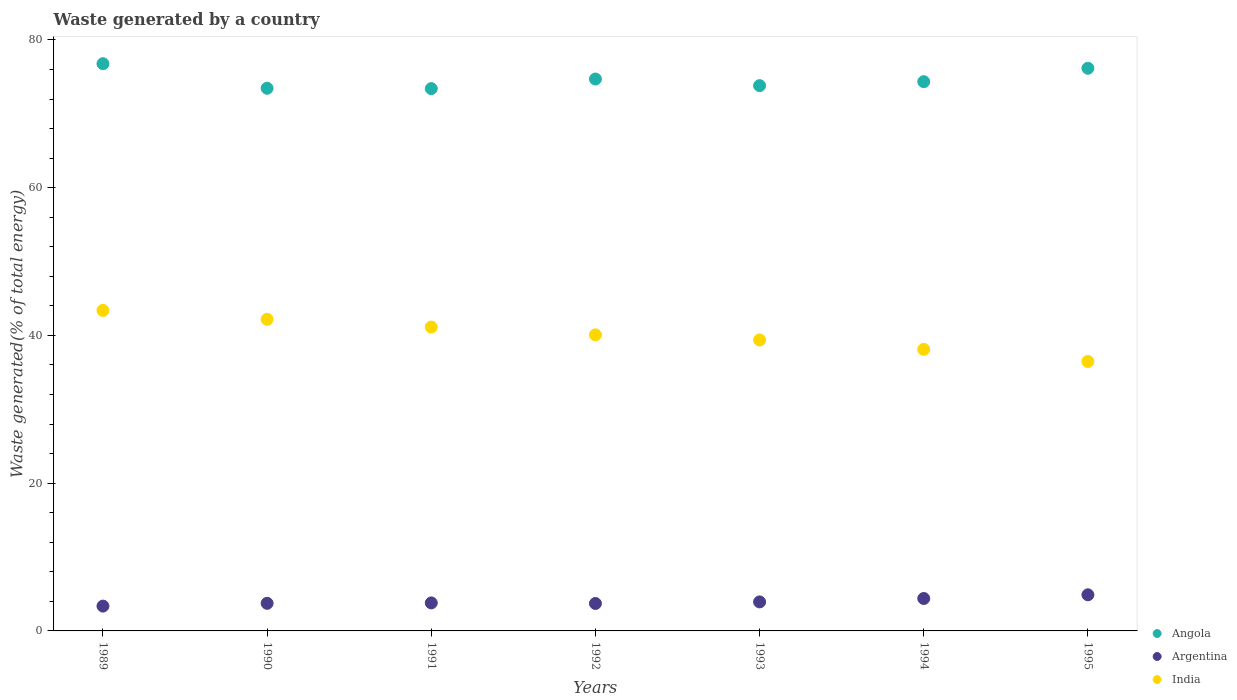Is the number of dotlines equal to the number of legend labels?
Your answer should be compact. Yes. What is the total waste generated in India in 1992?
Your answer should be compact. 40.08. Across all years, what is the maximum total waste generated in Argentina?
Offer a very short reply. 4.89. Across all years, what is the minimum total waste generated in Argentina?
Your answer should be very brief. 3.36. In which year was the total waste generated in India maximum?
Provide a short and direct response. 1989. In which year was the total waste generated in Argentina minimum?
Make the answer very short. 1989. What is the total total waste generated in Angola in the graph?
Your answer should be very brief. 522.7. What is the difference between the total waste generated in Argentina in 1992 and that in 1994?
Offer a very short reply. -0.67. What is the difference between the total waste generated in Angola in 1994 and the total waste generated in Argentina in 1992?
Offer a terse response. 70.64. What is the average total waste generated in Argentina per year?
Ensure brevity in your answer.  3.97. In the year 1990, what is the difference between the total waste generated in Angola and total waste generated in Argentina?
Make the answer very short. 69.72. In how many years, is the total waste generated in Argentina greater than 48 %?
Provide a succinct answer. 0. What is the ratio of the total waste generated in Argentina in 1990 to that in 1995?
Offer a very short reply. 0.76. Is the total waste generated in Argentina in 1991 less than that in 1992?
Provide a succinct answer. No. What is the difference between the highest and the second highest total waste generated in Angola?
Ensure brevity in your answer.  0.62. What is the difference between the highest and the lowest total waste generated in Angola?
Offer a very short reply. 3.37. Is the sum of the total waste generated in India in 1989 and 1995 greater than the maximum total waste generated in Angola across all years?
Provide a succinct answer. Yes. Is it the case that in every year, the sum of the total waste generated in India and total waste generated in Argentina  is greater than the total waste generated in Angola?
Your answer should be very brief. No. Is the total waste generated in Angola strictly greater than the total waste generated in Argentina over the years?
Ensure brevity in your answer.  Yes. How many years are there in the graph?
Keep it short and to the point. 7. Are the values on the major ticks of Y-axis written in scientific E-notation?
Your response must be concise. No. Does the graph contain any zero values?
Provide a short and direct response. No. Does the graph contain grids?
Make the answer very short. No. How many legend labels are there?
Provide a succinct answer. 3. How are the legend labels stacked?
Offer a very short reply. Vertical. What is the title of the graph?
Your answer should be compact. Waste generated by a country. Does "Senegal" appear as one of the legend labels in the graph?
Offer a very short reply. No. What is the label or title of the Y-axis?
Ensure brevity in your answer.  Waste generated(% of total energy). What is the Waste generated(% of total energy) in Angola in 1989?
Provide a succinct answer. 76.79. What is the Waste generated(% of total energy) of Argentina in 1989?
Give a very brief answer. 3.36. What is the Waste generated(% of total energy) in India in 1989?
Your answer should be compact. 43.39. What is the Waste generated(% of total energy) of Angola in 1990?
Give a very brief answer. 73.46. What is the Waste generated(% of total energy) of Argentina in 1990?
Make the answer very short. 3.74. What is the Waste generated(% of total energy) in India in 1990?
Make the answer very short. 42.18. What is the Waste generated(% of total energy) in Angola in 1991?
Offer a terse response. 73.42. What is the Waste generated(% of total energy) of Argentina in 1991?
Provide a succinct answer. 3.79. What is the Waste generated(% of total energy) of India in 1991?
Offer a very short reply. 41.13. What is the Waste generated(% of total energy) in Angola in 1992?
Offer a very short reply. 74.71. What is the Waste generated(% of total energy) in Argentina in 1992?
Provide a short and direct response. 3.71. What is the Waste generated(% of total energy) of India in 1992?
Provide a succinct answer. 40.08. What is the Waste generated(% of total energy) in Angola in 1993?
Offer a very short reply. 73.82. What is the Waste generated(% of total energy) of Argentina in 1993?
Offer a very short reply. 3.93. What is the Waste generated(% of total energy) in India in 1993?
Offer a very short reply. 39.39. What is the Waste generated(% of total energy) of Angola in 1994?
Your answer should be compact. 74.35. What is the Waste generated(% of total energy) of Argentina in 1994?
Your answer should be compact. 4.39. What is the Waste generated(% of total energy) of India in 1994?
Ensure brevity in your answer.  38.12. What is the Waste generated(% of total energy) in Angola in 1995?
Make the answer very short. 76.17. What is the Waste generated(% of total energy) in Argentina in 1995?
Make the answer very short. 4.89. What is the Waste generated(% of total energy) of India in 1995?
Provide a succinct answer. 36.47. Across all years, what is the maximum Waste generated(% of total energy) in Angola?
Offer a very short reply. 76.79. Across all years, what is the maximum Waste generated(% of total energy) in Argentina?
Give a very brief answer. 4.89. Across all years, what is the maximum Waste generated(% of total energy) in India?
Provide a succinct answer. 43.39. Across all years, what is the minimum Waste generated(% of total energy) of Angola?
Provide a short and direct response. 73.42. Across all years, what is the minimum Waste generated(% of total energy) of Argentina?
Your response must be concise. 3.36. Across all years, what is the minimum Waste generated(% of total energy) of India?
Your answer should be compact. 36.47. What is the total Waste generated(% of total energy) in Angola in the graph?
Ensure brevity in your answer.  522.7. What is the total Waste generated(% of total energy) of Argentina in the graph?
Offer a terse response. 27.81. What is the total Waste generated(% of total energy) in India in the graph?
Offer a very short reply. 280.75. What is the difference between the Waste generated(% of total energy) of Angola in 1989 and that in 1990?
Keep it short and to the point. 3.33. What is the difference between the Waste generated(% of total energy) of Argentina in 1989 and that in 1990?
Your response must be concise. -0.38. What is the difference between the Waste generated(% of total energy) of India in 1989 and that in 1990?
Offer a terse response. 1.2. What is the difference between the Waste generated(% of total energy) of Angola in 1989 and that in 1991?
Ensure brevity in your answer.  3.37. What is the difference between the Waste generated(% of total energy) in Argentina in 1989 and that in 1991?
Offer a terse response. -0.43. What is the difference between the Waste generated(% of total energy) of India in 1989 and that in 1991?
Make the answer very short. 2.25. What is the difference between the Waste generated(% of total energy) in Angola in 1989 and that in 1992?
Make the answer very short. 2.08. What is the difference between the Waste generated(% of total energy) in Argentina in 1989 and that in 1992?
Provide a succinct answer. -0.35. What is the difference between the Waste generated(% of total energy) of India in 1989 and that in 1992?
Your response must be concise. 3.31. What is the difference between the Waste generated(% of total energy) of Angola in 1989 and that in 1993?
Ensure brevity in your answer.  2.97. What is the difference between the Waste generated(% of total energy) in Argentina in 1989 and that in 1993?
Your answer should be compact. -0.57. What is the difference between the Waste generated(% of total energy) of India in 1989 and that in 1993?
Provide a short and direct response. 4. What is the difference between the Waste generated(% of total energy) in Angola in 1989 and that in 1994?
Your answer should be compact. 2.44. What is the difference between the Waste generated(% of total energy) of Argentina in 1989 and that in 1994?
Offer a terse response. -1.03. What is the difference between the Waste generated(% of total energy) in India in 1989 and that in 1994?
Your answer should be very brief. 5.27. What is the difference between the Waste generated(% of total energy) in Angola in 1989 and that in 1995?
Your answer should be very brief. 0.62. What is the difference between the Waste generated(% of total energy) of Argentina in 1989 and that in 1995?
Offer a terse response. -1.53. What is the difference between the Waste generated(% of total energy) in India in 1989 and that in 1995?
Your response must be concise. 6.91. What is the difference between the Waste generated(% of total energy) of Angola in 1990 and that in 1991?
Ensure brevity in your answer.  0.04. What is the difference between the Waste generated(% of total energy) of Argentina in 1990 and that in 1991?
Provide a short and direct response. -0.06. What is the difference between the Waste generated(% of total energy) in India in 1990 and that in 1991?
Make the answer very short. 1.05. What is the difference between the Waste generated(% of total energy) of Angola in 1990 and that in 1992?
Make the answer very short. -1.25. What is the difference between the Waste generated(% of total energy) of Argentina in 1990 and that in 1992?
Make the answer very short. 0.02. What is the difference between the Waste generated(% of total energy) of India in 1990 and that in 1992?
Your answer should be compact. 2.1. What is the difference between the Waste generated(% of total energy) of Angola in 1990 and that in 1993?
Keep it short and to the point. -0.36. What is the difference between the Waste generated(% of total energy) in Argentina in 1990 and that in 1993?
Provide a succinct answer. -0.19. What is the difference between the Waste generated(% of total energy) in India in 1990 and that in 1993?
Ensure brevity in your answer.  2.8. What is the difference between the Waste generated(% of total energy) of Angola in 1990 and that in 1994?
Offer a terse response. -0.89. What is the difference between the Waste generated(% of total energy) of Argentina in 1990 and that in 1994?
Give a very brief answer. -0.65. What is the difference between the Waste generated(% of total energy) of India in 1990 and that in 1994?
Provide a succinct answer. 4.06. What is the difference between the Waste generated(% of total energy) of Angola in 1990 and that in 1995?
Offer a terse response. -2.71. What is the difference between the Waste generated(% of total energy) in Argentina in 1990 and that in 1995?
Offer a very short reply. -1.15. What is the difference between the Waste generated(% of total energy) in India in 1990 and that in 1995?
Keep it short and to the point. 5.71. What is the difference between the Waste generated(% of total energy) of Angola in 1991 and that in 1992?
Your answer should be compact. -1.29. What is the difference between the Waste generated(% of total energy) in Argentina in 1991 and that in 1992?
Your response must be concise. 0.08. What is the difference between the Waste generated(% of total energy) of India in 1991 and that in 1992?
Make the answer very short. 1.06. What is the difference between the Waste generated(% of total energy) of Angola in 1991 and that in 1993?
Your answer should be compact. -0.4. What is the difference between the Waste generated(% of total energy) of Argentina in 1991 and that in 1993?
Give a very brief answer. -0.14. What is the difference between the Waste generated(% of total energy) in India in 1991 and that in 1993?
Your response must be concise. 1.75. What is the difference between the Waste generated(% of total energy) of Angola in 1991 and that in 1994?
Offer a very short reply. -0.94. What is the difference between the Waste generated(% of total energy) of Argentina in 1991 and that in 1994?
Make the answer very short. -0.6. What is the difference between the Waste generated(% of total energy) of India in 1991 and that in 1994?
Your answer should be very brief. 3.02. What is the difference between the Waste generated(% of total energy) of Angola in 1991 and that in 1995?
Your answer should be very brief. -2.75. What is the difference between the Waste generated(% of total energy) of Argentina in 1991 and that in 1995?
Your response must be concise. -1.1. What is the difference between the Waste generated(% of total energy) in India in 1991 and that in 1995?
Provide a short and direct response. 4.66. What is the difference between the Waste generated(% of total energy) of Angola in 1992 and that in 1993?
Offer a terse response. 0.89. What is the difference between the Waste generated(% of total energy) of Argentina in 1992 and that in 1993?
Give a very brief answer. -0.21. What is the difference between the Waste generated(% of total energy) in India in 1992 and that in 1993?
Give a very brief answer. 0.69. What is the difference between the Waste generated(% of total energy) of Angola in 1992 and that in 1994?
Your answer should be very brief. 0.36. What is the difference between the Waste generated(% of total energy) of Argentina in 1992 and that in 1994?
Your response must be concise. -0.67. What is the difference between the Waste generated(% of total energy) in India in 1992 and that in 1994?
Make the answer very short. 1.96. What is the difference between the Waste generated(% of total energy) of Angola in 1992 and that in 1995?
Ensure brevity in your answer.  -1.46. What is the difference between the Waste generated(% of total energy) in Argentina in 1992 and that in 1995?
Your response must be concise. -1.17. What is the difference between the Waste generated(% of total energy) of India in 1992 and that in 1995?
Your answer should be compact. 3.6. What is the difference between the Waste generated(% of total energy) in Angola in 1993 and that in 1994?
Offer a terse response. -0.53. What is the difference between the Waste generated(% of total energy) of Argentina in 1993 and that in 1994?
Offer a very short reply. -0.46. What is the difference between the Waste generated(% of total energy) of India in 1993 and that in 1994?
Give a very brief answer. 1.27. What is the difference between the Waste generated(% of total energy) in Angola in 1993 and that in 1995?
Your answer should be very brief. -2.35. What is the difference between the Waste generated(% of total energy) in Argentina in 1993 and that in 1995?
Offer a very short reply. -0.96. What is the difference between the Waste generated(% of total energy) in India in 1993 and that in 1995?
Make the answer very short. 2.91. What is the difference between the Waste generated(% of total energy) in Angola in 1994 and that in 1995?
Your answer should be compact. -1.82. What is the difference between the Waste generated(% of total energy) of Argentina in 1994 and that in 1995?
Your answer should be compact. -0.5. What is the difference between the Waste generated(% of total energy) of India in 1994 and that in 1995?
Keep it short and to the point. 1.65. What is the difference between the Waste generated(% of total energy) in Angola in 1989 and the Waste generated(% of total energy) in Argentina in 1990?
Keep it short and to the point. 73.05. What is the difference between the Waste generated(% of total energy) in Angola in 1989 and the Waste generated(% of total energy) in India in 1990?
Offer a very short reply. 34.61. What is the difference between the Waste generated(% of total energy) in Argentina in 1989 and the Waste generated(% of total energy) in India in 1990?
Your answer should be compact. -38.82. What is the difference between the Waste generated(% of total energy) of Angola in 1989 and the Waste generated(% of total energy) of Argentina in 1991?
Ensure brevity in your answer.  72.99. What is the difference between the Waste generated(% of total energy) in Angola in 1989 and the Waste generated(% of total energy) in India in 1991?
Ensure brevity in your answer.  35.65. What is the difference between the Waste generated(% of total energy) in Argentina in 1989 and the Waste generated(% of total energy) in India in 1991?
Ensure brevity in your answer.  -37.77. What is the difference between the Waste generated(% of total energy) in Angola in 1989 and the Waste generated(% of total energy) in Argentina in 1992?
Ensure brevity in your answer.  73.07. What is the difference between the Waste generated(% of total energy) in Angola in 1989 and the Waste generated(% of total energy) in India in 1992?
Provide a short and direct response. 36.71. What is the difference between the Waste generated(% of total energy) in Argentina in 1989 and the Waste generated(% of total energy) in India in 1992?
Your answer should be very brief. -36.72. What is the difference between the Waste generated(% of total energy) of Angola in 1989 and the Waste generated(% of total energy) of Argentina in 1993?
Your answer should be very brief. 72.86. What is the difference between the Waste generated(% of total energy) of Angola in 1989 and the Waste generated(% of total energy) of India in 1993?
Offer a very short reply. 37.4. What is the difference between the Waste generated(% of total energy) in Argentina in 1989 and the Waste generated(% of total energy) in India in 1993?
Provide a short and direct response. -36.02. What is the difference between the Waste generated(% of total energy) in Angola in 1989 and the Waste generated(% of total energy) in Argentina in 1994?
Ensure brevity in your answer.  72.4. What is the difference between the Waste generated(% of total energy) in Angola in 1989 and the Waste generated(% of total energy) in India in 1994?
Provide a succinct answer. 38.67. What is the difference between the Waste generated(% of total energy) in Argentina in 1989 and the Waste generated(% of total energy) in India in 1994?
Your response must be concise. -34.76. What is the difference between the Waste generated(% of total energy) in Angola in 1989 and the Waste generated(% of total energy) in Argentina in 1995?
Offer a very short reply. 71.9. What is the difference between the Waste generated(% of total energy) of Angola in 1989 and the Waste generated(% of total energy) of India in 1995?
Ensure brevity in your answer.  40.31. What is the difference between the Waste generated(% of total energy) of Argentina in 1989 and the Waste generated(% of total energy) of India in 1995?
Provide a short and direct response. -33.11. What is the difference between the Waste generated(% of total energy) of Angola in 1990 and the Waste generated(% of total energy) of Argentina in 1991?
Offer a terse response. 69.67. What is the difference between the Waste generated(% of total energy) in Angola in 1990 and the Waste generated(% of total energy) in India in 1991?
Keep it short and to the point. 32.33. What is the difference between the Waste generated(% of total energy) of Argentina in 1990 and the Waste generated(% of total energy) of India in 1991?
Provide a short and direct response. -37.4. What is the difference between the Waste generated(% of total energy) of Angola in 1990 and the Waste generated(% of total energy) of Argentina in 1992?
Your answer should be very brief. 69.75. What is the difference between the Waste generated(% of total energy) in Angola in 1990 and the Waste generated(% of total energy) in India in 1992?
Provide a succinct answer. 33.38. What is the difference between the Waste generated(% of total energy) in Argentina in 1990 and the Waste generated(% of total energy) in India in 1992?
Provide a succinct answer. -36.34. What is the difference between the Waste generated(% of total energy) of Angola in 1990 and the Waste generated(% of total energy) of Argentina in 1993?
Provide a succinct answer. 69.53. What is the difference between the Waste generated(% of total energy) in Angola in 1990 and the Waste generated(% of total energy) in India in 1993?
Offer a terse response. 34.07. What is the difference between the Waste generated(% of total energy) in Argentina in 1990 and the Waste generated(% of total energy) in India in 1993?
Offer a terse response. -35.65. What is the difference between the Waste generated(% of total energy) of Angola in 1990 and the Waste generated(% of total energy) of Argentina in 1994?
Offer a very short reply. 69.07. What is the difference between the Waste generated(% of total energy) of Angola in 1990 and the Waste generated(% of total energy) of India in 1994?
Offer a very short reply. 35.34. What is the difference between the Waste generated(% of total energy) in Argentina in 1990 and the Waste generated(% of total energy) in India in 1994?
Provide a succinct answer. -34.38. What is the difference between the Waste generated(% of total energy) of Angola in 1990 and the Waste generated(% of total energy) of Argentina in 1995?
Make the answer very short. 68.57. What is the difference between the Waste generated(% of total energy) in Angola in 1990 and the Waste generated(% of total energy) in India in 1995?
Offer a terse response. 36.99. What is the difference between the Waste generated(% of total energy) in Argentina in 1990 and the Waste generated(% of total energy) in India in 1995?
Offer a very short reply. -32.74. What is the difference between the Waste generated(% of total energy) of Angola in 1991 and the Waste generated(% of total energy) of Argentina in 1992?
Keep it short and to the point. 69.7. What is the difference between the Waste generated(% of total energy) of Angola in 1991 and the Waste generated(% of total energy) of India in 1992?
Provide a short and direct response. 33.34. What is the difference between the Waste generated(% of total energy) in Argentina in 1991 and the Waste generated(% of total energy) in India in 1992?
Your answer should be compact. -36.29. What is the difference between the Waste generated(% of total energy) in Angola in 1991 and the Waste generated(% of total energy) in Argentina in 1993?
Offer a very short reply. 69.49. What is the difference between the Waste generated(% of total energy) in Angola in 1991 and the Waste generated(% of total energy) in India in 1993?
Offer a very short reply. 34.03. What is the difference between the Waste generated(% of total energy) in Argentina in 1991 and the Waste generated(% of total energy) in India in 1993?
Provide a short and direct response. -35.59. What is the difference between the Waste generated(% of total energy) in Angola in 1991 and the Waste generated(% of total energy) in Argentina in 1994?
Offer a very short reply. 69.03. What is the difference between the Waste generated(% of total energy) in Angola in 1991 and the Waste generated(% of total energy) in India in 1994?
Provide a short and direct response. 35.3. What is the difference between the Waste generated(% of total energy) of Argentina in 1991 and the Waste generated(% of total energy) of India in 1994?
Provide a short and direct response. -34.33. What is the difference between the Waste generated(% of total energy) in Angola in 1991 and the Waste generated(% of total energy) in Argentina in 1995?
Your answer should be very brief. 68.53. What is the difference between the Waste generated(% of total energy) of Angola in 1991 and the Waste generated(% of total energy) of India in 1995?
Provide a succinct answer. 36.94. What is the difference between the Waste generated(% of total energy) in Argentina in 1991 and the Waste generated(% of total energy) in India in 1995?
Provide a short and direct response. -32.68. What is the difference between the Waste generated(% of total energy) in Angola in 1992 and the Waste generated(% of total energy) in Argentina in 1993?
Your answer should be very brief. 70.78. What is the difference between the Waste generated(% of total energy) in Angola in 1992 and the Waste generated(% of total energy) in India in 1993?
Your answer should be very brief. 35.32. What is the difference between the Waste generated(% of total energy) in Argentina in 1992 and the Waste generated(% of total energy) in India in 1993?
Your answer should be compact. -35.67. What is the difference between the Waste generated(% of total energy) of Angola in 1992 and the Waste generated(% of total energy) of Argentina in 1994?
Give a very brief answer. 70.32. What is the difference between the Waste generated(% of total energy) of Angola in 1992 and the Waste generated(% of total energy) of India in 1994?
Offer a terse response. 36.59. What is the difference between the Waste generated(% of total energy) of Argentina in 1992 and the Waste generated(% of total energy) of India in 1994?
Offer a terse response. -34.4. What is the difference between the Waste generated(% of total energy) in Angola in 1992 and the Waste generated(% of total energy) in Argentina in 1995?
Offer a very short reply. 69.82. What is the difference between the Waste generated(% of total energy) in Angola in 1992 and the Waste generated(% of total energy) in India in 1995?
Provide a short and direct response. 38.24. What is the difference between the Waste generated(% of total energy) in Argentina in 1992 and the Waste generated(% of total energy) in India in 1995?
Offer a very short reply. -32.76. What is the difference between the Waste generated(% of total energy) of Angola in 1993 and the Waste generated(% of total energy) of Argentina in 1994?
Make the answer very short. 69.43. What is the difference between the Waste generated(% of total energy) of Angola in 1993 and the Waste generated(% of total energy) of India in 1994?
Offer a terse response. 35.7. What is the difference between the Waste generated(% of total energy) in Argentina in 1993 and the Waste generated(% of total energy) in India in 1994?
Keep it short and to the point. -34.19. What is the difference between the Waste generated(% of total energy) of Angola in 1993 and the Waste generated(% of total energy) of Argentina in 1995?
Your answer should be very brief. 68.93. What is the difference between the Waste generated(% of total energy) in Angola in 1993 and the Waste generated(% of total energy) in India in 1995?
Your answer should be compact. 37.34. What is the difference between the Waste generated(% of total energy) in Argentina in 1993 and the Waste generated(% of total energy) in India in 1995?
Provide a succinct answer. -32.54. What is the difference between the Waste generated(% of total energy) in Angola in 1994 and the Waste generated(% of total energy) in Argentina in 1995?
Your response must be concise. 69.46. What is the difference between the Waste generated(% of total energy) of Angola in 1994 and the Waste generated(% of total energy) of India in 1995?
Offer a very short reply. 37.88. What is the difference between the Waste generated(% of total energy) of Argentina in 1994 and the Waste generated(% of total energy) of India in 1995?
Your answer should be very brief. -32.08. What is the average Waste generated(% of total energy) in Angola per year?
Provide a succinct answer. 74.67. What is the average Waste generated(% of total energy) in Argentina per year?
Make the answer very short. 3.97. What is the average Waste generated(% of total energy) of India per year?
Your answer should be compact. 40.11. In the year 1989, what is the difference between the Waste generated(% of total energy) in Angola and Waste generated(% of total energy) in Argentina?
Your answer should be compact. 73.43. In the year 1989, what is the difference between the Waste generated(% of total energy) in Angola and Waste generated(% of total energy) in India?
Provide a succinct answer. 33.4. In the year 1989, what is the difference between the Waste generated(% of total energy) in Argentina and Waste generated(% of total energy) in India?
Make the answer very short. -40.02. In the year 1990, what is the difference between the Waste generated(% of total energy) of Angola and Waste generated(% of total energy) of Argentina?
Your answer should be very brief. 69.72. In the year 1990, what is the difference between the Waste generated(% of total energy) of Angola and Waste generated(% of total energy) of India?
Your answer should be compact. 31.28. In the year 1990, what is the difference between the Waste generated(% of total energy) of Argentina and Waste generated(% of total energy) of India?
Your response must be concise. -38.44. In the year 1991, what is the difference between the Waste generated(% of total energy) of Angola and Waste generated(% of total energy) of Argentina?
Make the answer very short. 69.62. In the year 1991, what is the difference between the Waste generated(% of total energy) in Angola and Waste generated(% of total energy) in India?
Provide a short and direct response. 32.28. In the year 1991, what is the difference between the Waste generated(% of total energy) of Argentina and Waste generated(% of total energy) of India?
Provide a succinct answer. -37.34. In the year 1992, what is the difference between the Waste generated(% of total energy) in Angola and Waste generated(% of total energy) in Argentina?
Offer a terse response. 70.99. In the year 1992, what is the difference between the Waste generated(% of total energy) of Angola and Waste generated(% of total energy) of India?
Give a very brief answer. 34.63. In the year 1992, what is the difference between the Waste generated(% of total energy) in Argentina and Waste generated(% of total energy) in India?
Provide a short and direct response. -36.36. In the year 1993, what is the difference between the Waste generated(% of total energy) of Angola and Waste generated(% of total energy) of Argentina?
Make the answer very short. 69.89. In the year 1993, what is the difference between the Waste generated(% of total energy) in Angola and Waste generated(% of total energy) in India?
Provide a short and direct response. 34.43. In the year 1993, what is the difference between the Waste generated(% of total energy) of Argentina and Waste generated(% of total energy) of India?
Make the answer very short. -35.46. In the year 1994, what is the difference between the Waste generated(% of total energy) of Angola and Waste generated(% of total energy) of Argentina?
Provide a succinct answer. 69.96. In the year 1994, what is the difference between the Waste generated(% of total energy) of Angola and Waste generated(% of total energy) of India?
Ensure brevity in your answer.  36.23. In the year 1994, what is the difference between the Waste generated(% of total energy) in Argentina and Waste generated(% of total energy) in India?
Your response must be concise. -33.73. In the year 1995, what is the difference between the Waste generated(% of total energy) of Angola and Waste generated(% of total energy) of Argentina?
Provide a short and direct response. 71.28. In the year 1995, what is the difference between the Waste generated(% of total energy) in Angola and Waste generated(% of total energy) in India?
Provide a short and direct response. 39.7. In the year 1995, what is the difference between the Waste generated(% of total energy) of Argentina and Waste generated(% of total energy) of India?
Keep it short and to the point. -31.58. What is the ratio of the Waste generated(% of total energy) in Angola in 1989 to that in 1990?
Give a very brief answer. 1.05. What is the ratio of the Waste generated(% of total energy) of Argentina in 1989 to that in 1990?
Ensure brevity in your answer.  0.9. What is the ratio of the Waste generated(% of total energy) of India in 1989 to that in 1990?
Offer a very short reply. 1.03. What is the ratio of the Waste generated(% of total energy) in Angola in 1989 to that in 1991?
Ensure brevity in your answer.  1.05. What is the ratio of the Waste generated(% of total energy) of Argentina in 1989 to that in 1991?
Your response must be concise. 0.89. What is the ratio of the Waste generated(% of total energy) in India in 1989 to that in 1991?
Give a very brief answer. 1.05. What is the ratio of the Waste generated(% of total energy) in Angola in 1989 to that in 1992?
Offer a very short reply. 1.03. What is the ratio of the Waste generated(% of total energy) in Argentina in 1989 to that in 1992?
Ensure brevity in your answer.  0.9. What is the ratio of the Waste generated(% of total energy) of India in 1989 to that in 1992?
Give a very brief answer. 1.08. What is the ratio of the Waste generated(% of total energy) in Angola in 1989 to that in 1993?
Make the answer very short. 1.04. What is the ratio of the Waste generated(% of total energy) in Argentina in 1989 to that in 1993?
Ensure brevity in your answer.  0.86. What is the ratio of the Waste generated(% of total energy) of India in 1989 to that in 1993?
Ensure brevity in your answer.  1.1. What is the ratio of the Waste generated(% of total energy) in Angola in 1989 to that in 1994?
Your answer should be very brief. 1.03. What is the ratio of the Waste generated(% of total energy) in Argentina in 1989 to that in 1994?
Make the answer very short. 0.77. What is the ratio of the Waste generated(% of total energy) of India in 1989 to that in 1994?
Keep it short and to the point. 1.14. What is the ratio of the Waste generated(% of total energy) of Argentina in 1989 to that in 1995?
Offer a terse response. 0.69. What is the ratio of the Waste generated(% of total energy) of India in 1989 to that in 1995?
Give a very brief answer. 1.19. What is the ratio of the Waste generated(% of total energy) of Argentina in 1990 to that in 1991?
Offer a very short reply. 0.99. What is the ratio of the Waste generated(% of total energy) in India in 1990 to that in 1991?
Provide a short and direct response. 1.03. What is the ratio of the Waste generated(% of total energy) of Angola in 1990 to that in 1992?
Ensure brevity in your answer.  0.98. What is the ratio of the Waste generated(% of total energy) in Argentina in 1990 to that in 1992?
Your response must be concise. 1.01. What is the ratio of the Waste generated(% of total energy) of India in 1990 to that in 1992?
Offer a terse response. 1.05. What is the ratio of the Waste generated(% of total energy) in Argentina in 1990 to that in 1993?
Provide a succinct answer. 0.95. What is the ratio of the Waste generated(% of total energy) in India in 1990 to that in 1993?
Keep it short and to the point. 1.07. What is the ratio of the Waste generated(% of total energy) in Argentina in 1990 to that in 1994?
Provide a succinct answer. 0.85. What is the ratio of the Waste generated(% of total energy) in India in 1990 to that in 1994?
Your response must be concise. 1.11. What is the ratio of the Waste generated(% of total energy) in Angola in 1990 to that in 1995?
Keep it short and to the point. 0.96. What is the ratio of the Waste generated(% of total energy) of Argentina in 1990 to that in 1995?
Make the answer very short. 0.76. What is the ratio of the Waste generated(% of total energy) of India in 1990 to that in 1995?
Ensure brevity in your answer.  1.16. What is the ratio of the Waste generated(% of total energy) of Angola in 1991 to that in 1992?
Provide a short and direct response. 0.98. What is the ratio of the Waste generated(% of total energy) of Argentina in 1991 to that in 1992?
Your answer should be compact. 1.02. What is the ratio of the Waste generated(% of total energy) of India in 1991 to that in 1992?
Provide a succinct answer. 1.03. What is the ratio of the Waste generated(% of total energy) in Angola in 1991 to that in 1993?
Your response must be concise. 0.99. What is the ratio of the Waste generated(% of total energy) in Argentina in 1991 to that in 1993?
Ensure brevity in your answer.  0.97. What is the ratio of the Waste generated(% of total energy) of India in 1991 to that in 1993?
Your answer should be very brief. 1.04. What is the ratio of the Waste generated(% of total energy) in Angola in 1991 to that in 1994?
Keep it short and to the point. 0.99. What is the ratio of the Waste generated(% of total energy) of Argentina in 1991 to that in 1994?
Your answer should be very brief. 0.86. What is the ratio of the Waste generated(% of total energy) of India in 1991 to that in 1994?
Provide a short and direct response. 1.08. What is the ratio of the Waste generated(% of total energy) of Angola in 1991 to that in 1995?
Provide a short and direct response. 0.96. What is the ratio of the Waste generated(% of total energy) of Argentina in 1991 to that in 1995?
Provide a short and direct response. 0.78. What is the ratio of the Waste generated(% of total energy) of India in 1991 to that in 1995?
Give a very brief answer. 1.13. What is the ratio of the Waste generated(% of total energy) of Angola in 1992 to that in 1993?
Keep it short and to the point. 1.01. What is the ratio of the Waste generated(% of total energy) of Argentina in 1992 to that in 1993?
Your answer should be very brief. 0.95. What is the ratio of the Waste generated(% of total energy) of India in 1992 to that in 1993?
Offer a terse response. 1.02. What is the ratio of the Waste generated(% of total energy) of Argentina in 1992 to that in 1994?
Provide a succinct answer. 0.85. What is the ratio of the Waste generated(% of total energy) of India in 1992 to that in 1994?
Ensure brevity in your answer.  1.05. What is the ratio of the Waste generated(% of total energy) of Angola in 1992 to that in 1995?
Your answer should be very brief. 0.98. What is the ratio of the Waste generated(% of total energy) of Argentina in 1992 to that in 1995?
Make the answer very short. 0.76. What is the ratio of the Waste generated(% of total energy) in India in 1992 to that in 1995?
Offer a terse response. 1.1. What is the ratio of the Waste generated(% of total energy) in Angola in 1993 to that in 1994?
Your response must be concise. 0.99. What is the ratio of the Waste generated(% of total energy) of Argentina in 1993 to that in 1994?
Keep it short and to the point. 0.9. What is the ratio of the Waste generated(% of total energy) of India in 1993 to that in 1994?
Keep it short and to the point. 1.03. What is the ratio of the Waste generated(% of total energy) of Angola in 1993 to that in 1995?
Offer a very short reply. 0.97. What is the ratio of the Waste generated(% of total energy) in Argentina in 1993 to that in 1995?
Give a very brief answer. 0.8. What is the ratio of the Waste generated(% of total energy) of India in 1993 to that in 1995?
Keep it short and to the point. 1.08. What is the ratio of the Waste generated(% of total energy) in Angola in 1994 to that in 1995?
Give a very brief answer. 0.98. What is the ratio of the Waste generated(% of total energy) of Argentina in 1994 to that in 1995?
Keep it short and to the point. 0.9. What is the ratio of the Waste generated(% of total energy) of India in 1994 to that in 1995?
Your response must be concise. 1.05. What is the difference between the highest and the second highest Waste generated(% of total energy) of Angola?
Your answer should be very brief. 0.62. What is the difference between the highest and the second highest Waste generated(% of total energy) in Argentina?
Provide a succinct answer. 0.5. What is the difference between the highest and the second highest Waste generated(% of total energy) in India?
Keep it short and to the point. 1.2. What is the difference between the highest and the lowest Waste generated(% of total energy) of Angola?
Ensure brevity in your answer.  3.37. What is the difference between the highest and the lowest Waste generated(% of total energy) of Argentina?
Keep it short and to the point. 1.53. What is the difference between the highest and the lowest Waste generated(% of total energy) in India?
Keep it short and to the point. 6.91. 